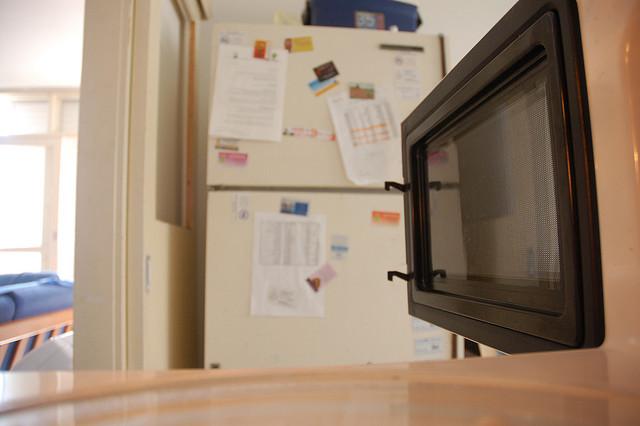What ARE WE LOOKING OUT OF?
Give a very brief answer. Microwave. What is on the clipboard?
Concise answer only. Paper. Are the doors closed?
Short answer required. No. Should a human be looking out of a microwave?
Write a very short answer. No. Is the microwave on?
Keep it brief. No. What is the microwave sitting on?
Answer briefly. Counter. What kind of room is this?
Answer briefly. Kitchen. Why is the refrigerator empty?
Keep it brief. It's not. Is there an ice cream flavor that matches this microwave?
Answer briefly. No. Is it sunset?
Concise answer only. No. Is the refrigerator door bare?
Keep it brief. No. Is the giraffe inside or outside?
Answer briefly. Outside. What are the 2 black knobs for?
Be succinct. Control. 